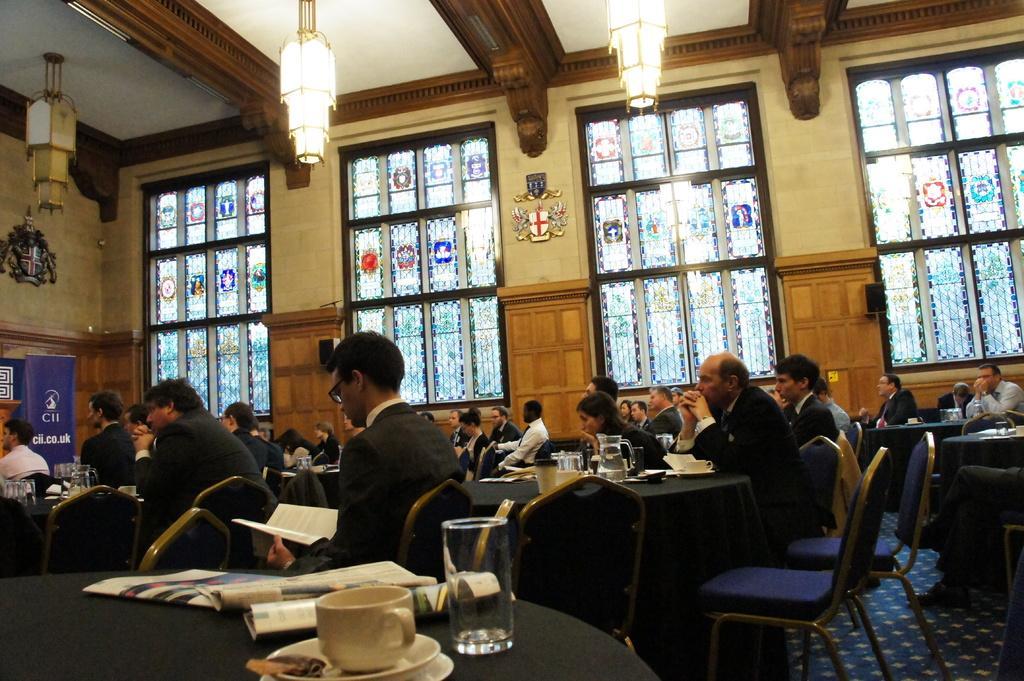Describe this image in one or two sentences. This picture shows a group of people seated on the chairs and we see some glasses, tea cups and papers on the table and we see a man reading book holding in his hands and we see couple of lights 